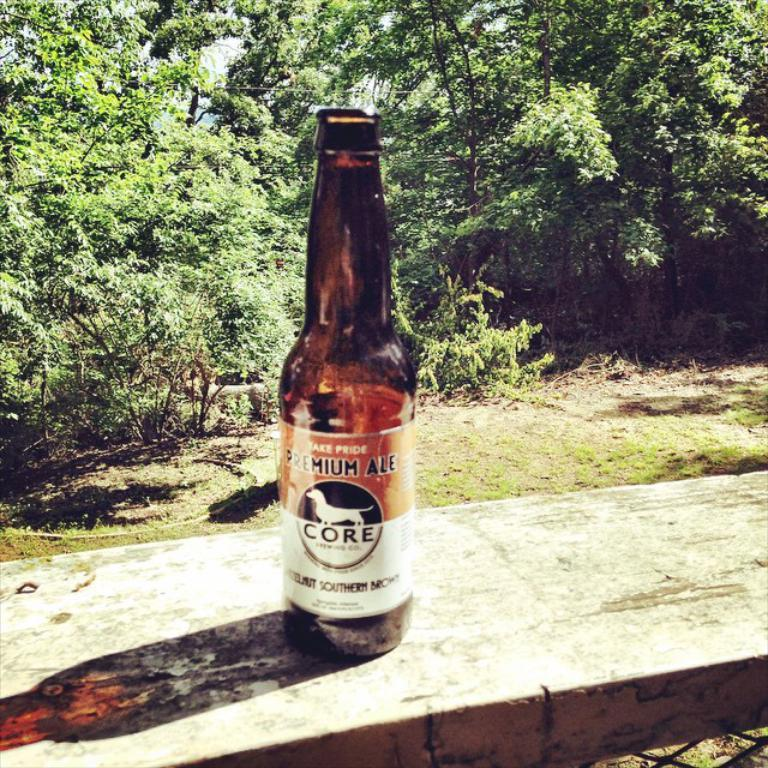What object is located in the foreground of the image? There is a glass bottle in the foreground of the image. On what is the glass bottle placed? The glass bottle is on a rock block. What can be seen in the background of the image? There are trees visible in the background of the image. What type of history can be seen in the image? There is no history visible in the image; it features a glass bottle on a rock block with trees in the background. 